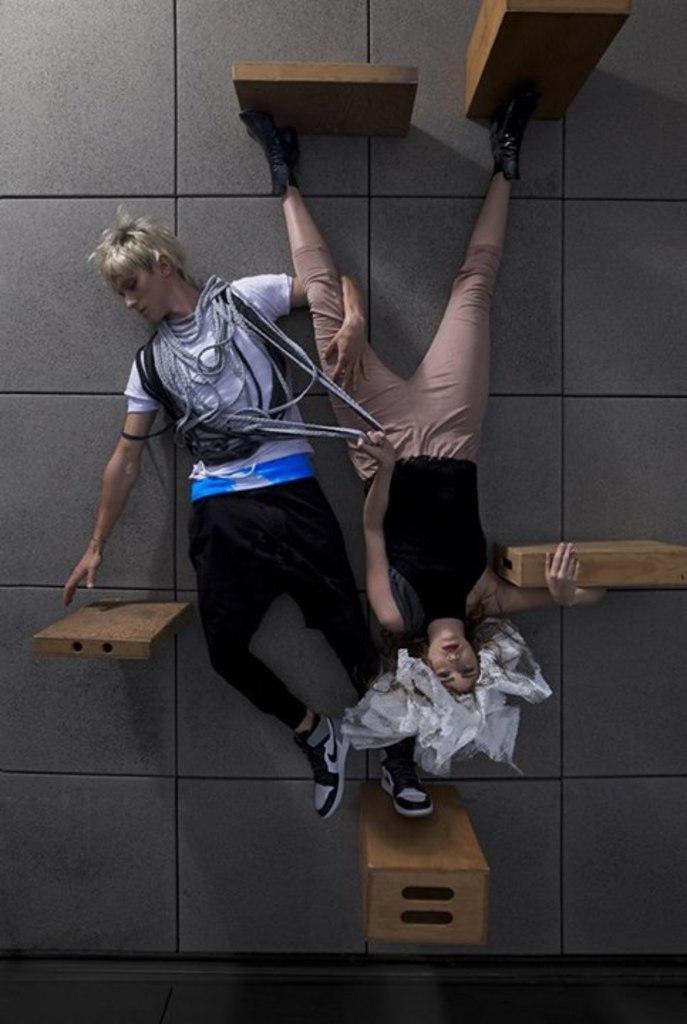Could you give a brief overview of what you see in this image? In this image there are two people laying on a floor and there are wooden blocks. 